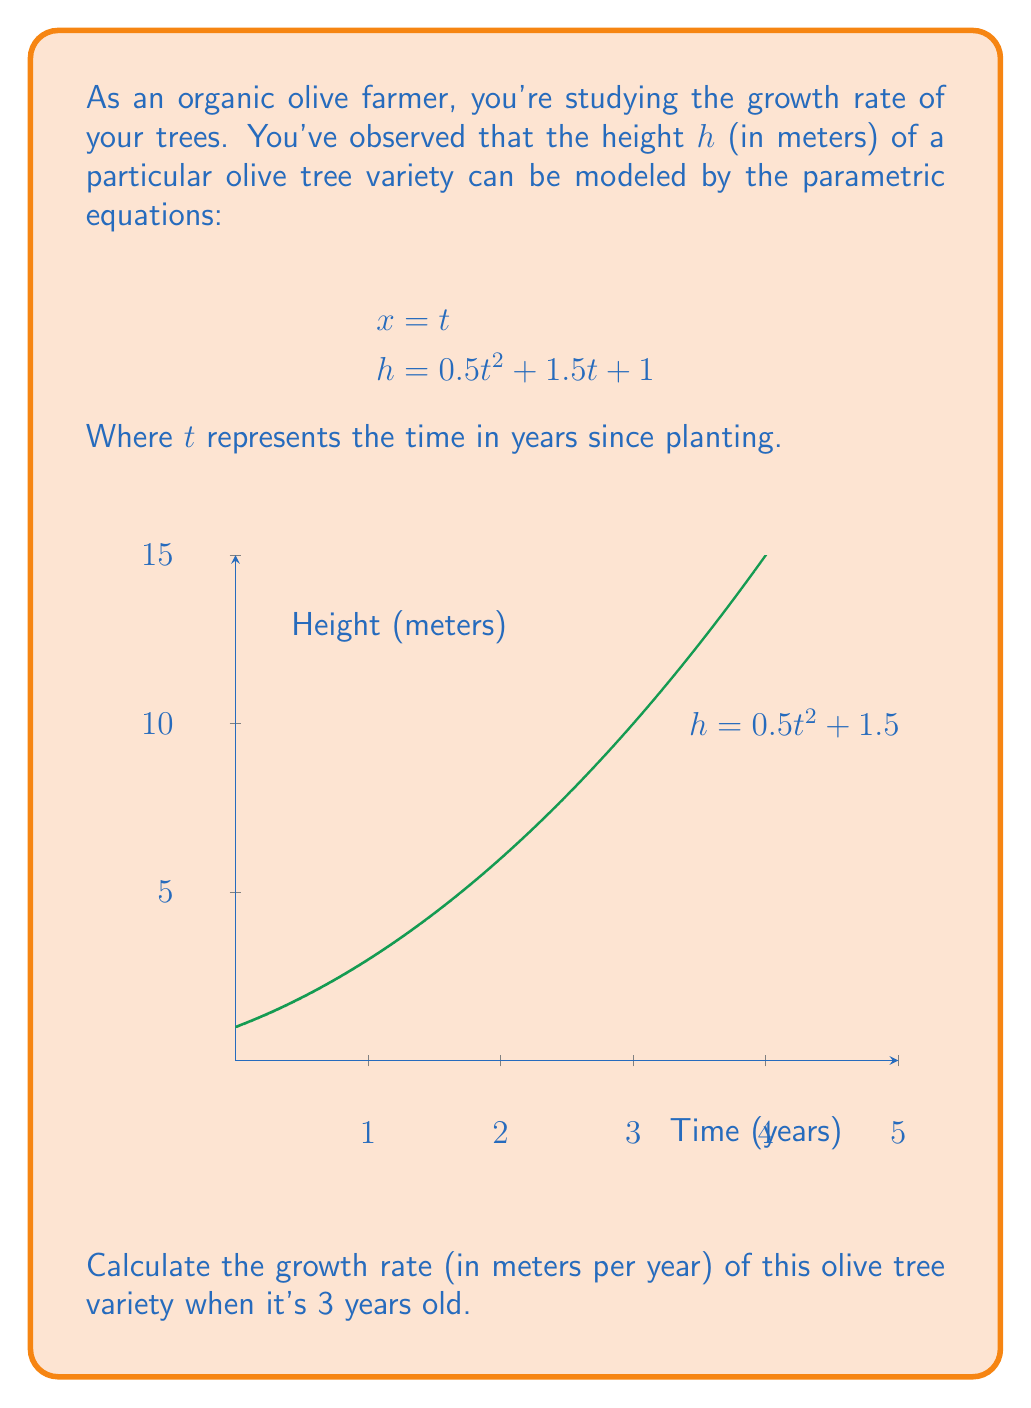Can you answer this question? To solve this problem, we need to follow these steps:

1) The growth rate is the rate of change of height with respect to time, which is equivalent to $\frac{dh}{dt}$.

2) To find $\frac{dh}{dt}$, we need to use the chain rule:

   $$\frac{dh}{dt} = \frac{dh}{dx} \cdot \frac{dx}{dt}$$

3) From the given equations:
   
   $$\frac{dx}{dt} = 1$$ (since $x = t$)

4) To find $\frac{dh}{dx}$, we need to differentiate $h$ with respect to $t$:

   $$\frac{dh}{dt} = 0.5 \cdot 2t + 1.5 = t + 1.5$$

5) Therefore:

   $$\frac{dh}{dt} = \frac{dh}{dx} \cdot \frac{dx}{dt} = (t + 1.5) \cdot 1 = t + 1.5$$

6) The question asks for the growth rate when the tree is 3 years old, so we substitute $t = 3$:

   Growth rate = $3 + 1.5 = 4.5$ meters per year
Answer: 4.5 m/year 